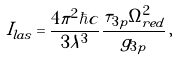Convert formula to latex. <formula><loc_0><loc_0><loc_500><loc_500>I _ { l a s } = \frac { 4 \pi ^ { 2 } \hbar { c } } { 3 \lambda ^ { 3 } } \frac { \tau _ { 3 p } \Omega ^ { 2 } _ { r e d } } { g _ { 3 p } } \, ,</formula> 